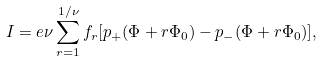Convert formula to latex. <formula><loc_0><loc_0><loc_500><loc_500>I = e \nu \sum _ { r = 1 } ^ { 1 / \nu } f _ { r } [ p _ { + } ( \Phi + r \Phi _ { 0 } ) - p _ { - } ( \Phi + r \Phi _ { 0 } ) ] ,</formula> 